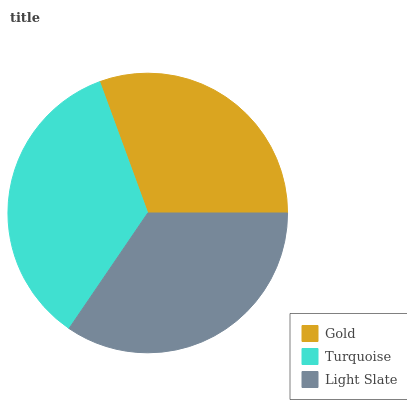Is Gold the minimum?
Answer yes or no. Yes. Is Turquoise the maximum?
Answer yes or no. Yes. Is Light Slate the minimum?
Answer yes or no. No. Is Light Slate the maximum?
Answer yes or no. No. Is Turquoise greater than Light Slate?
Answer yes or no. Yes. Is Light Slate less than Turquoise?
Answer yes or no. Yes. Is Light Slate greater than Turquoise?
Answer yes or no. No. Is Turquoise less than Light Slate?
Answer yes or no. No. Is Light Slate the high median?
Answer yes or no. Yes. Is Light Slate the low median?
Answer yes or no. Yes. Is Turquoise the high median?
Answer yes or no. No. Is Gold the low median?
Answer yes or no. No. 